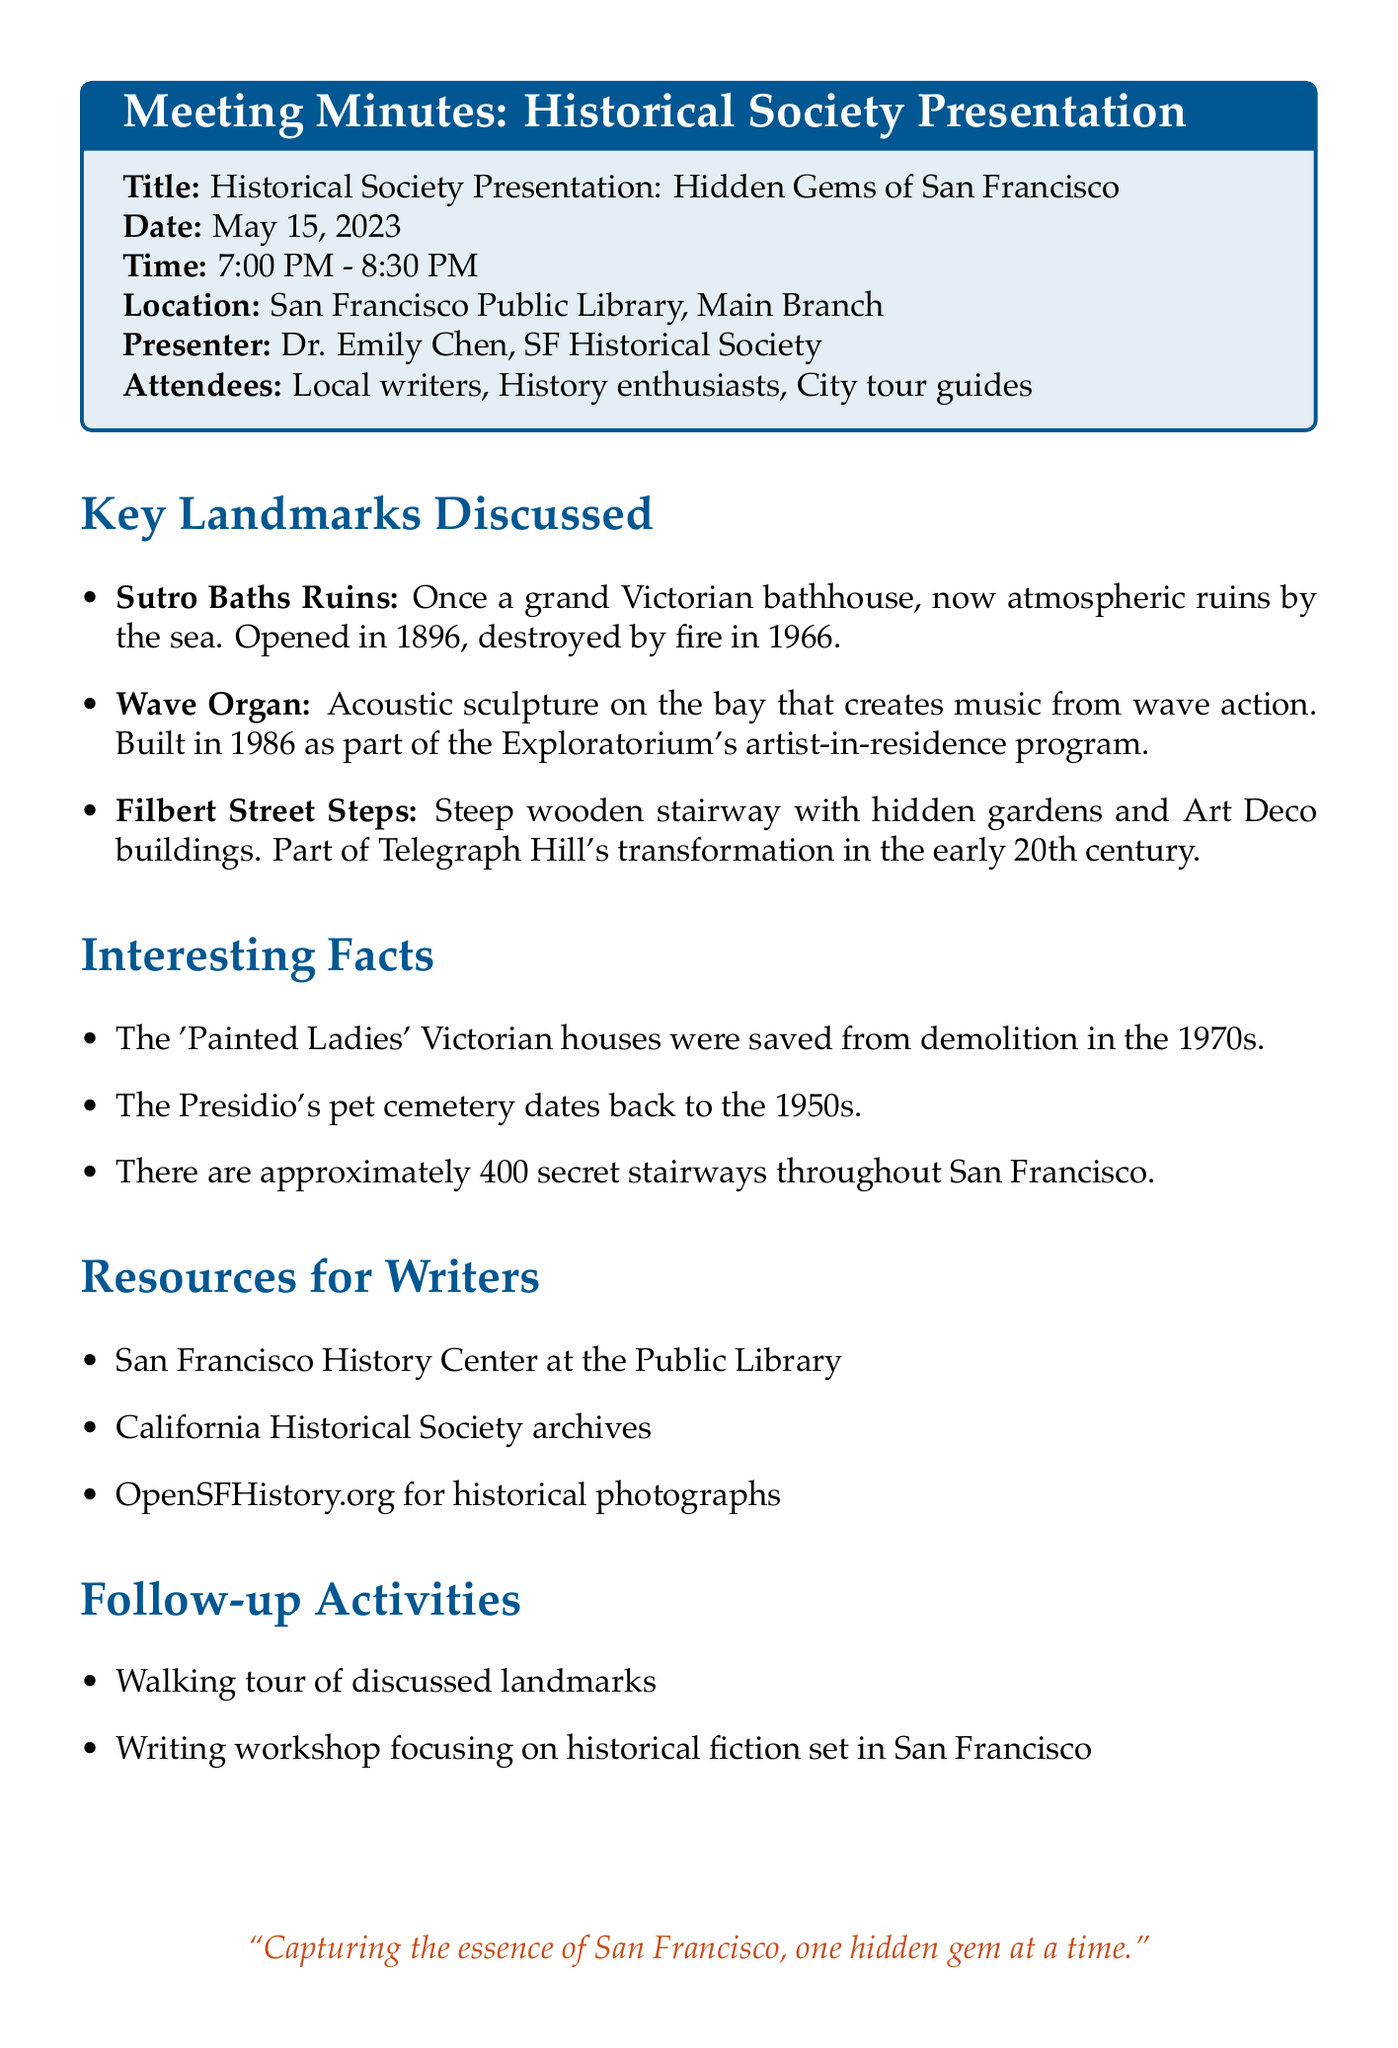What is the title of the presentation? The title of the presentation is the main subject that identifies the content of the meeting minutes.
Answer: Historical Society Presentation: Hidden Gems of San Francisco Who was the presenter? The presenter is the individual responsible for delivering the presentation and leading the discussion during the meeting.
Answer: Dr. Emily Chen, SF Historical Society When did the meeting take place? The meeting date is the specific day when the event occurred, as noted in the document.
Answer: May 15, 2023 What is one of the key landmarks discussed? The key landmarks represent important locations highlighted in the presentation, showcasing lesser-known spots in San Francisco.
Answer: Sutro Baths Ruins What is the historical significance of the Wave Organ? The historical significance provides context about the landmark's background and importance as mentioned in the discussion.
Answer: Built in 1986 as part of the Exploratorium's artist-in-residence program What resources for writers are listed? These resources offer additional information and support for writers engaged in research or creative projects related to the city's history.
Answer: San Francisco History Center at the Public Library What follow-up activity involves exploring the landmarks? A follow-up activity is an organized event that encourages participants to engage further with the discussed content of the meeting.
Answer: Walking tour of discussed landmarks How many secret stairways are mentioned in the interesting facts? This number reveals interesting trivia that demonstrates the hidden aspects of the city, which may intrigue writers.
Answer: Approximately 400 What location hosted the meeting? The location provides the physical venue where the meeting was held, important for context.
Answer: San Francisco Public Library, Main Branch 